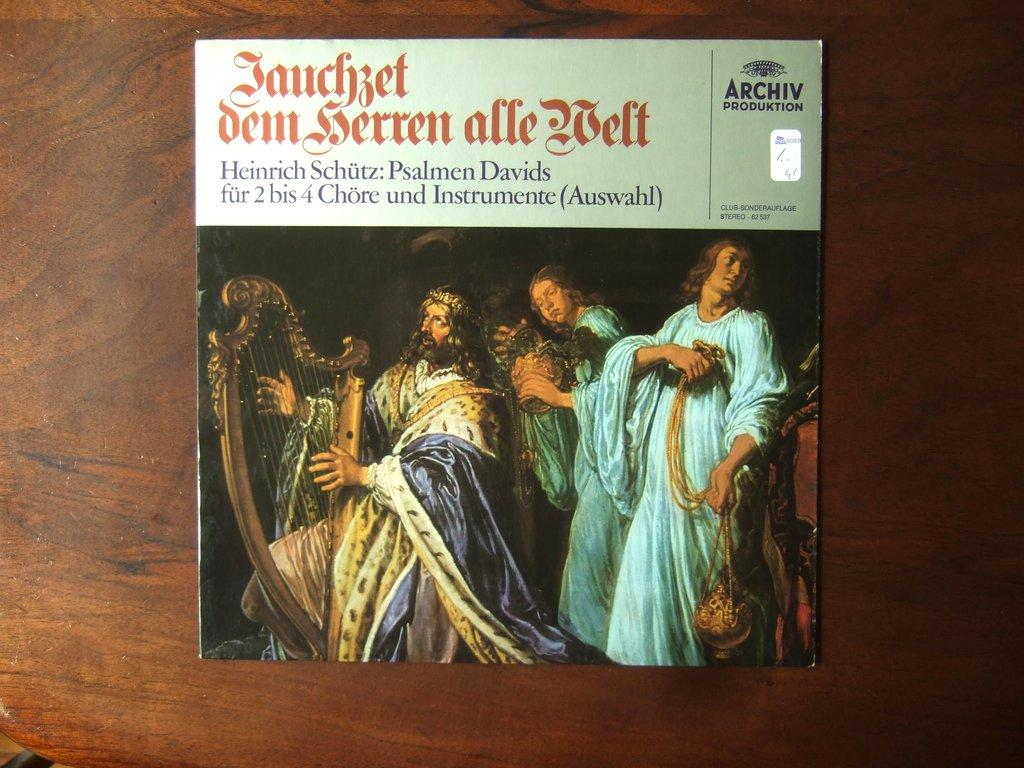<image>
Present a compact description of the photo's key features. A album of Janchzet dem serren alle welt 